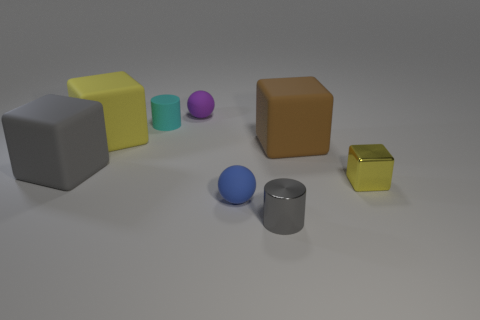What number of cyan rubber cylinders are in front of the small blue rubber object?
Make the answer very short. 0. Is the number of cyan things that are behind the yellow rubber thing less than the number of cyan rubber things?
Provide a succinct answer. No. The matte cylinder is what color?
Your answer should be compact. Cyan. Do the big matte cube that is in front of the brown matte object and the tiny metallic cylinder have the same color?
Your answer should be very brief. Yes. The tiny thing that is the same shape as the large gray matte thing is what color?
Offer a very short reply. Yellow. How many large things are gray shiny spheres or purple matte things?
Make the answer very short. 0. There is a thing that is behind the small cyan thing; what is its size?
Your answer should be very brief. Small. Are there any things of the same color as the tiny metal cylinder?
Your answer should be very brief. Yes. The large thing that is the same color as the tiny shiny cube is what shape?
Ensure brevity in your answer.  Cube. What number of gray things are to the right of the rubber thing to the left of the large yellow matte block?
Offer a very short reply. 1. 